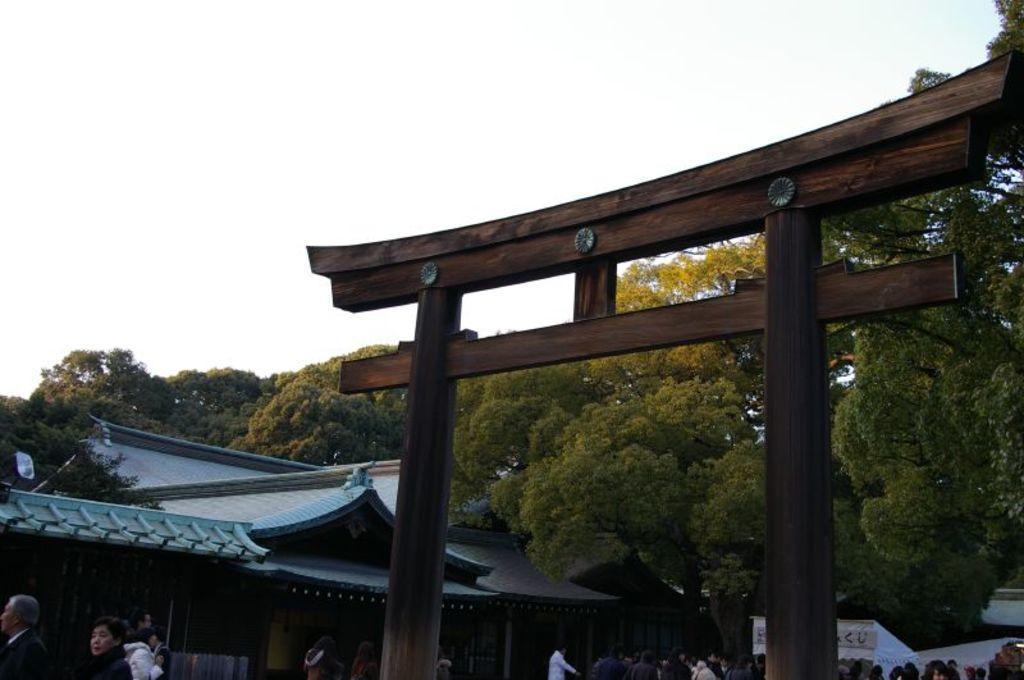In one or two sentences, can you explain what this image depicts? In this image, we can see sheds, people and tents. In the background, there is a wooden arch and there are trees and we can see some lights. At the top, there is sky. 